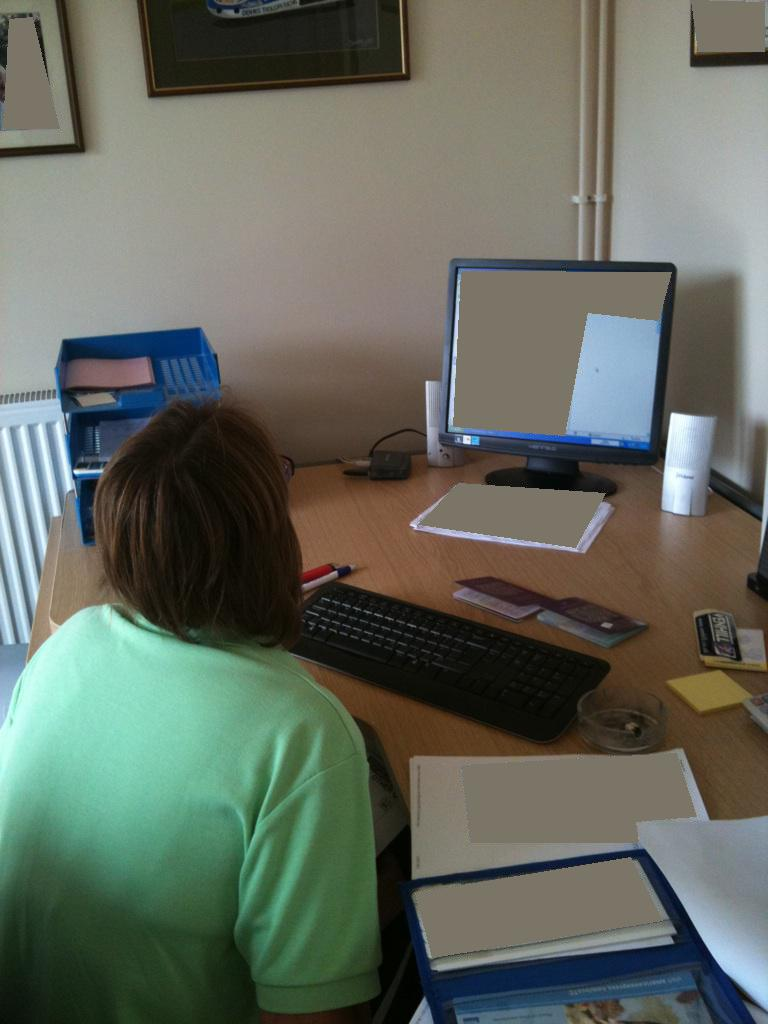Describe the workspace setup shown in the image. The workspace includes a cluttered desk with various documents, a monitor, a keyboard, and some personal items. There's a window to the left providing natural light, and the overall setup appears functional but crowded. 